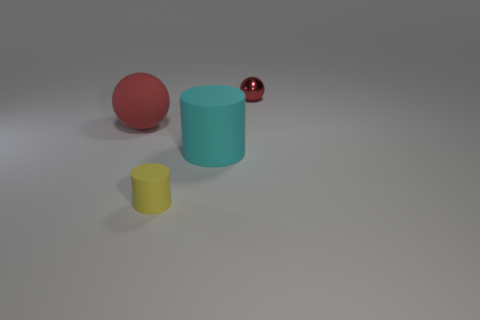What is the shape of the red object on the left side of the big rubber object right of the thing left of the small rubber object?
Provide a short and direct response. Sphere. What number of things are things that are behind the tiny rubber cylinder or tiny things in front of the shiny thing?
Give a very brief answer. 4. Are there any large cyan cylinders left of the yellow cylinder?
Provide a succinct answer. No. What number of things are either big red balls to the left of the tiny shiny sphere or yellow matte cylinders?
Offer a very short reply. 2. What number of red things are either metallic spheres or cylinders?
Provide a succinct answer. 1. What number of other objects are the same color as the rubber ball?
Provide a succinct answer. 1. Is the number of yellow matte cylinders that are behind the tiny yellow thing less than the number of cyan things?
Keep it short and to the point. Yes. What color is the matte thing on the right side of the small thing in front of the red sphere to the right of the large cyan object?
Make the answer very short. Cyan. Is there anything else that is the same material as the small red ball?
Your response must be concise. No. What size is the other matte object that is the same shape as the tiny yellow thing?
Offer a very short reply. Large. 